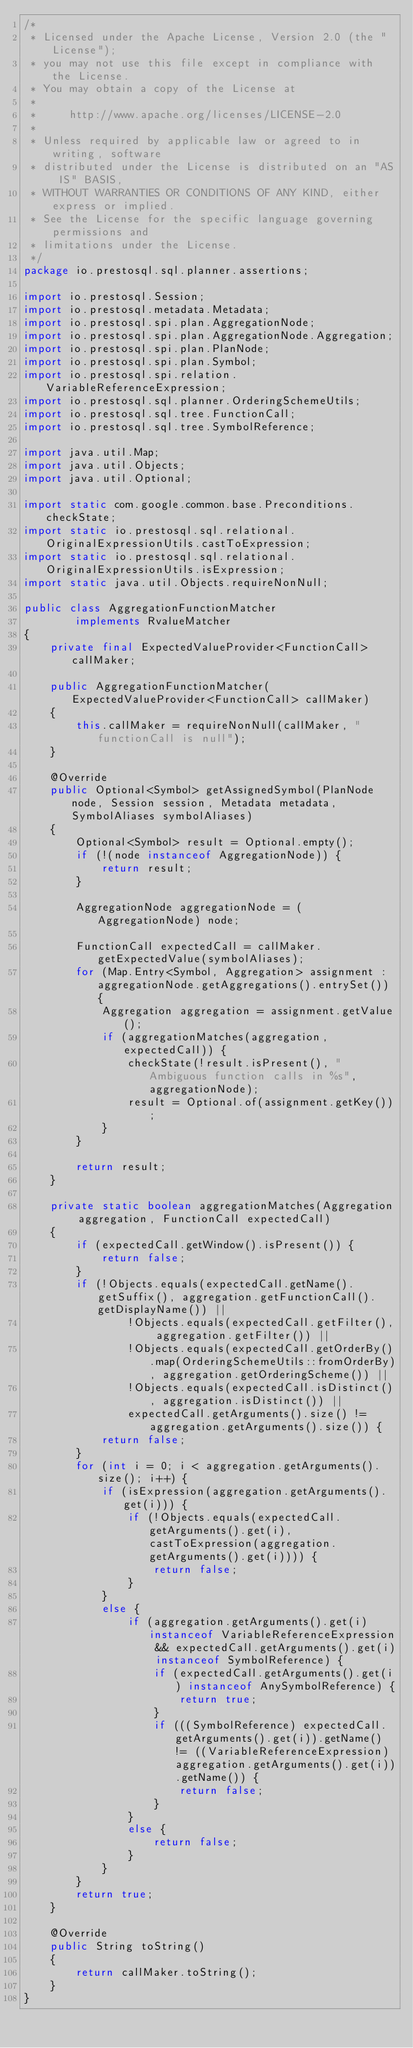<code> <loc_0><loc_0><loc_500><loc_500><_Java_>/*
 * Licensed under the Apache License, Version 2.0 (the "License");
 * you may not use this file except in compliance with the License.
 * You may obtain a copy of the License at
 *
 *     http://www.apache.org/licenses/LICENSE-2.0
 *
 * Unless required by applicable law or agreed to in writing, software
 * distributed under the License is distributed on an "AS IS" BASIS,
 * WITHOUT WARRANTIES OR CONDITIONS OF ANY KIND, either express or implied.
 * See the License for the specific language governing permissions and
 * limitations under the License.
 */
package io.prestosql.sql.planner.assertions;

import io.prestosql.Session;
import io.prestosql.metadata.Metadata;
import io.prestosql.spi.plan.AggregationNode;
import io.prestosql.spi.plan.AggregationNode.Aggregation;
import io.prestosql.spi.plan.PlanNode;
import io.prestosql.spi.plan.Symbol;
import io.prestosql.spi.relation.VariableReferenceExpression;
import io.prestosql.sql.planner.OrderingSchemeUtils;
import io.prestosql.sql.tree.FunctionCall;
import io.prestosql.sql.tree.SymbolReference;

import java.util.Map;
import java.util.Objects;
import java.util.Optional;

import static com.google.common.base.Preconditions.checkState;
import static io.prestosql.sql.relational.OriginalExpressionUtils.castToExpression;
import static io.prestosql.sql.relational.OriginalExpressionUtils.isExpression;
import static java.util.Objects.requireNonNull;

public class AggregationFunctionMatcher
        implements RvalueMatcher
{
    private final ExpectedValueProvider<FunctionCall> callMaker;

    public AggregationFunctionMatcher(ExpectedValueProvider<FunctionCall> callMaker)
    {
        this.callMaker = requireNonNull(callMaker, "functionCall is null");
    }

    @Override
    public Optional<Symbol> getAssignedSymbol(PlanNode node, Session session, Metadata metadata, SymbolAliases symbolAliases)
    {
        Optional<Symbol> result = Optional.empty();
        if (!(node instanceof AggregationNode)) {
            return result;
        }

        AggregationNode aggregationNode = (AggregationNode) node;

        FunctionCall expectedCall = callMaker.getExpectedValue(symbolAliases);
        for (Map.Entry<Symbol, Aggregation> assignment : aggregationNode.getAggregations().entrySet()) {
            Aggregation aggregation = assignment.getValue();
            if (aggregationMatches(aggregation, expectedCall)) {
                checkState(!result.isPresent(), "Ambiguous function calls in %s", aggregationNode);
                result = Optional.of(assignment.getKey());
            }
        }

        return result;
    }

    private static boolean aggregationMatches(Aggregation aggregation, FunctionCall expectedCall)
    {
        if (expectedCall.getWindow().isPresent()) {
            return false;
        }
        if (!Objects.equals(expectedCall.getName().getSuffix(), aggregation.getFunctionCall().getDisplayName()) ||
                !Objects.equals(expectedCall.getFilter(), aggregation.getFilter()) ||
                !Objects.equals(expectedCall.getOrderBy().map(OrderingSchemeUtils::fromOrderBy), aggregation.getOrderingScheme()) ||
                !Objects.equals(expectedCall.isDistinct(), aggregation.isDistinct()) ||
                expectedCall.getArguments().size() != aggregation.getArguments().size()) {
            return false;
        }
        for (int i = 0; i < aggregation.getArguments().size(); i++) {
            if (isExpression(aggregation.getArguments().get(i))) {
                if (!Objects.equals(expectedCall.getArguments().get(i), castToExpression(aggregation.getArguments().get(i)))) {
                    return false;
                }
            }
            else {
                if (aggregation.getArguments().get(i) instanceof VariableReferenceExpression && expectedCall.getArguments().get(i) instanceof SymbolReference) {
                    if (expectedCall.getArguments().get(i) instanceof AnySymbolReference) {
                        return true;
                    }
                    if (((SymbolReference) expectedCall.getArguments().get(i)).getName() != ((VariableReferenceExpression) aggregation.getArguments().get(i)).getName()) {
                        return false;
                    }
                }
                else {
                    return false;
                }
            }
        }
        return true;
    }

    @Override
    public String toString()
    {
        return callMaker.toString();
    }
}
</code> 